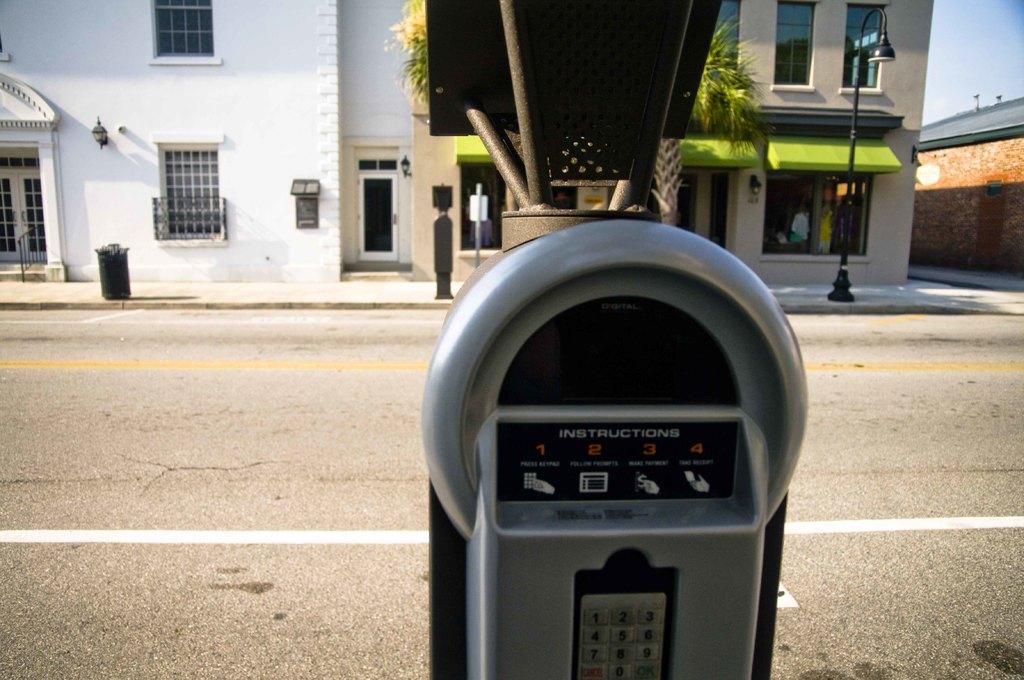How many instructions?
Ensure brevity in your answer.  4. 